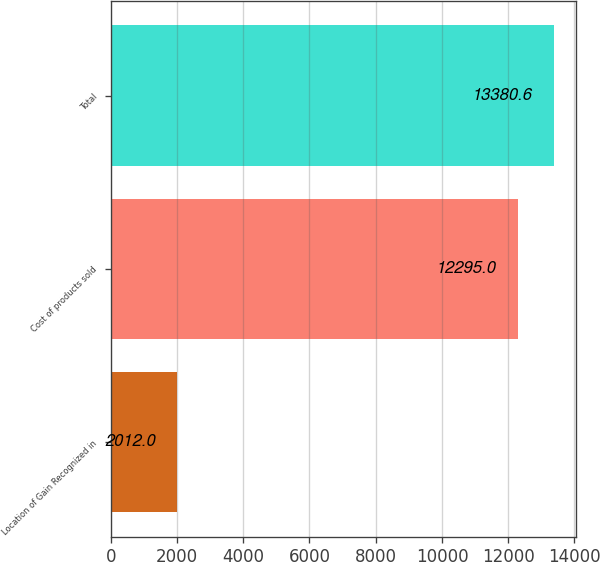<chart> <loc_0><loc_0><loc_500><loc_500><bar_chart><fcel>Location of Gain Recognized in<fcel>Cost of products sold<fcel>Total<nl><fcel>2012<fcel>12295<fcel>13380.6<nl></chart> 